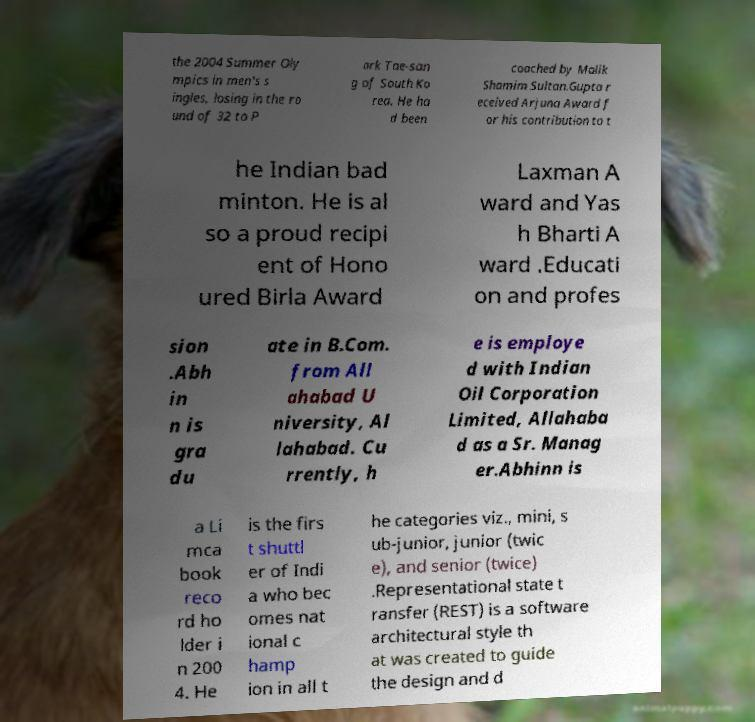There's text embedded in this image that I need extracted. Can you transcribe it verbatim? the 2004 Summer Oly mpics in men's s ingles, losing in the ro und of 32 to P ark Tae-san g of South Ko rea. He ha d been coached by Malik Shamim Sultan.Gupta r eceived Arjuna Award f or his contribution to t he Indian bad minton. He is al so a proud recipi ent of Hono ured Birla Award Laxman A ward and Yas h Bharti A ward .Educati on and profes sion .Abh in n is gra du ate in B.Com. from All ahabad U niversity, Al lahabad. Cu rrently, h e is employe d with Indian Oil Corporation Limited, Allahaba d as a Sr. Manag er.Abhinn is a Li mca book reco rd ho lder i n 200 4. He is the firs t shuttl er of Indi a who bec omes nat ional c hamp ion in all t he categories viz., mini, s ub-junior, junior (twic e), and senior (twice) .Representational state t ransfer (REST) is a software architectural style th at was created to guide the design and d 